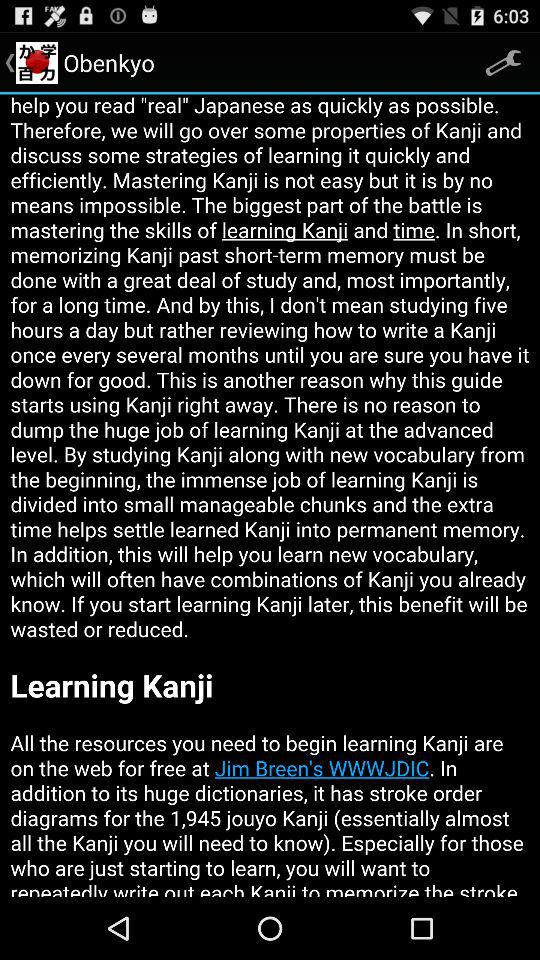What is the web address?
When the provided information is insufficient, respond with <no answer>. <no answer> 